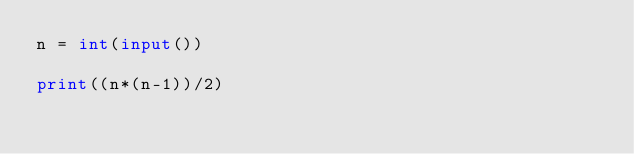Convert code to text. <code><loc_0><loc_0><loc_500><loc_500><_Python_>n = int(input())

print((n*(n-1))/2)</code> 